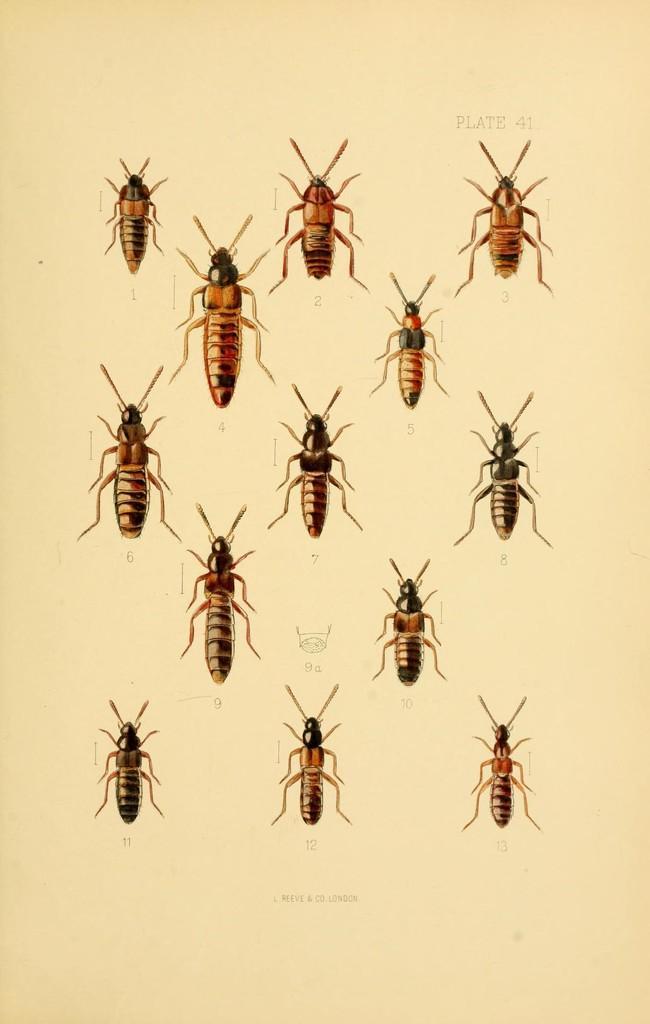How would you summarize this image in a sentence or two? In this image I can see an art of few insects on the cream colored paper. I can see something is written on the paper. 